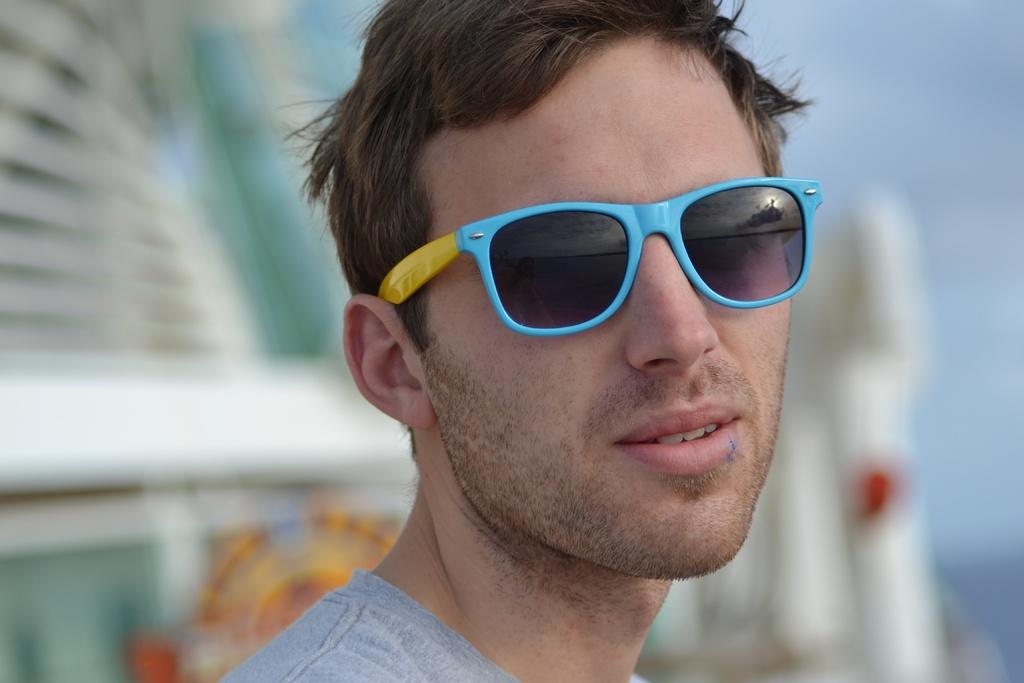Who or what is the main subject of the image? There is a person in the image. What is the person wearing on their upper body? The person is wearing a gray shirt. What type of eyewear is the person wearing? The person is wearing blue color spectacles. Can you describe the background of the image? The background of the image is blurred. What part of the natural environment is visible in the image? The sky is visible in the image. What type of cent can be seen in the image? There is no cent present in the image. What is the minister doing in the image? There is no minister present in the image. 